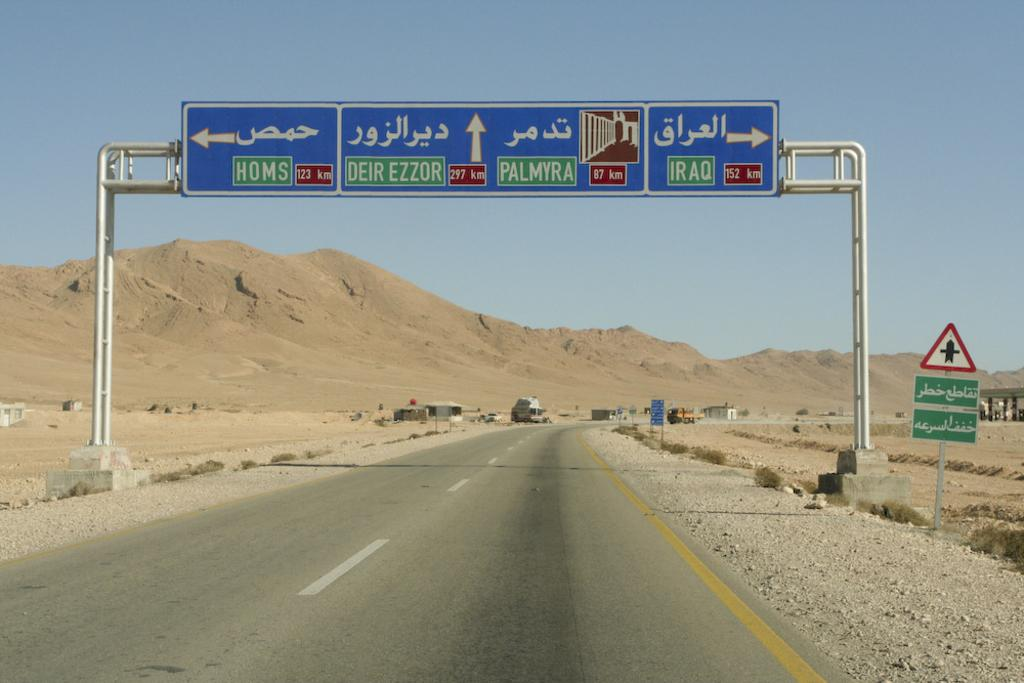<image>
Write a terse but informative summary of the picture. A highway sign points toward locations like Palmyra, Iraq and Homs. 